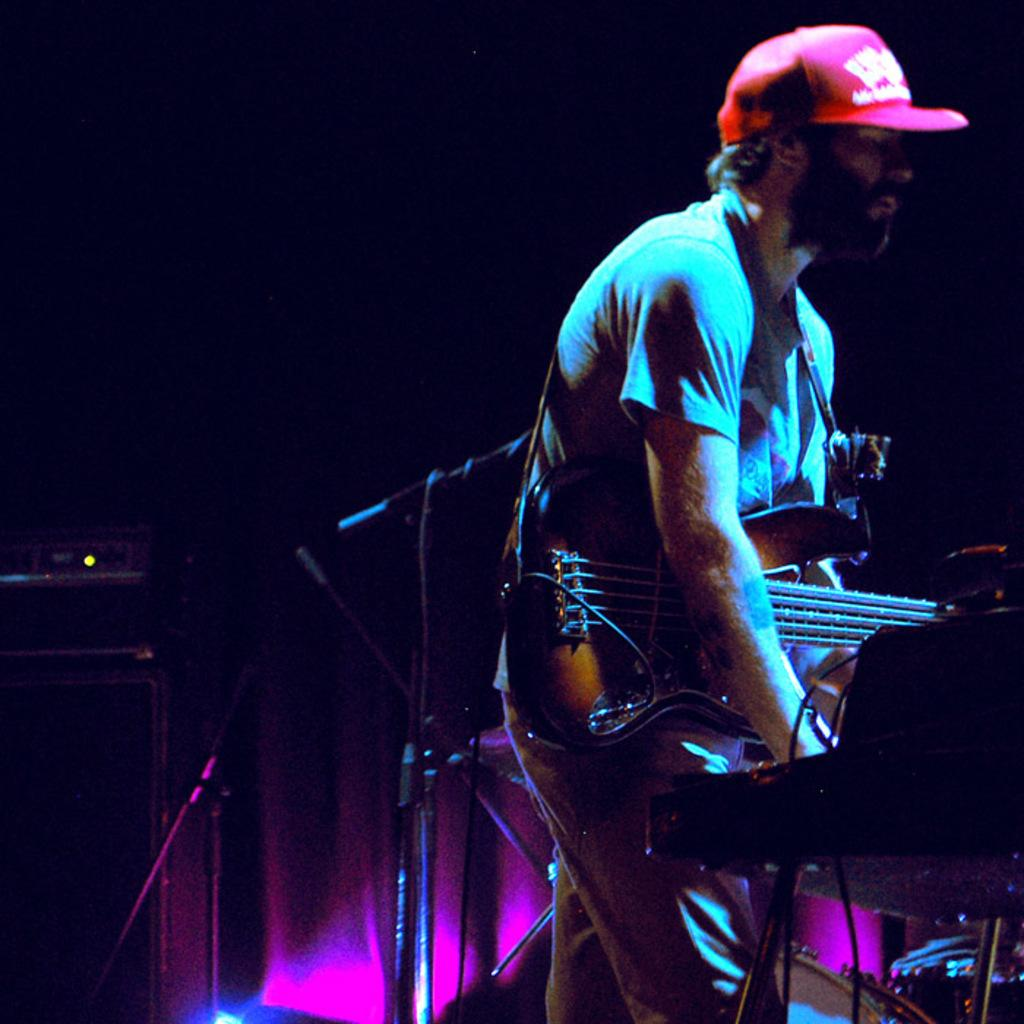What is the person in the image doing? The person is standing in the image and holding a guitar. What is the person wearing on their head? The person is wearing a cap. What equipment is present in the image for amplifying sound? There are microphones with stands in the image. What type of background can be seen in the image? There is a curtain in the image. What electronic device is visible in the image? There is an electrical device in the image. What type of science experiment is being conducted in the image? There is no science experiment present in the image; it features a person holding a guitar and other equipment related to music. What type of patch is sewn onto the person's clothing in the image? There is no patch visible on the person's clothing in the image. 